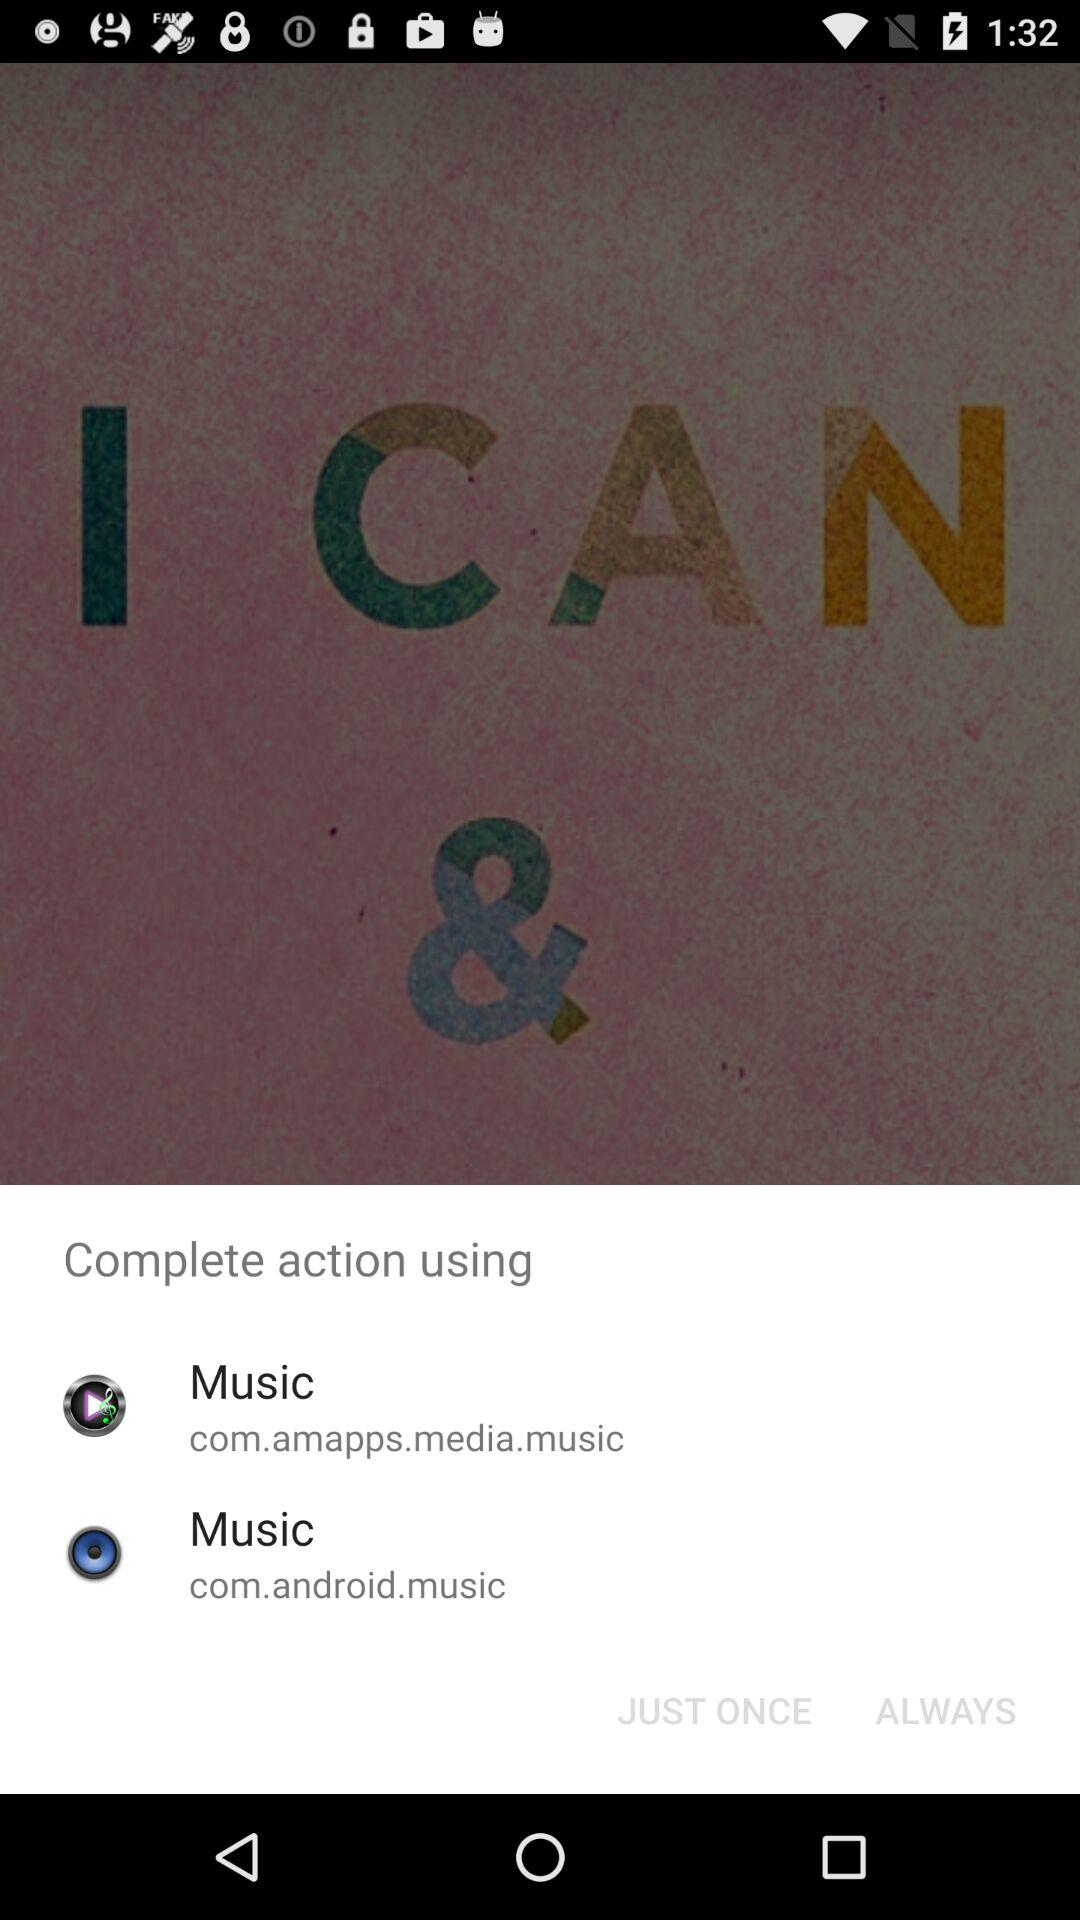How many music apps can I choose from?
Answer the question using a single word or phrase. 2 